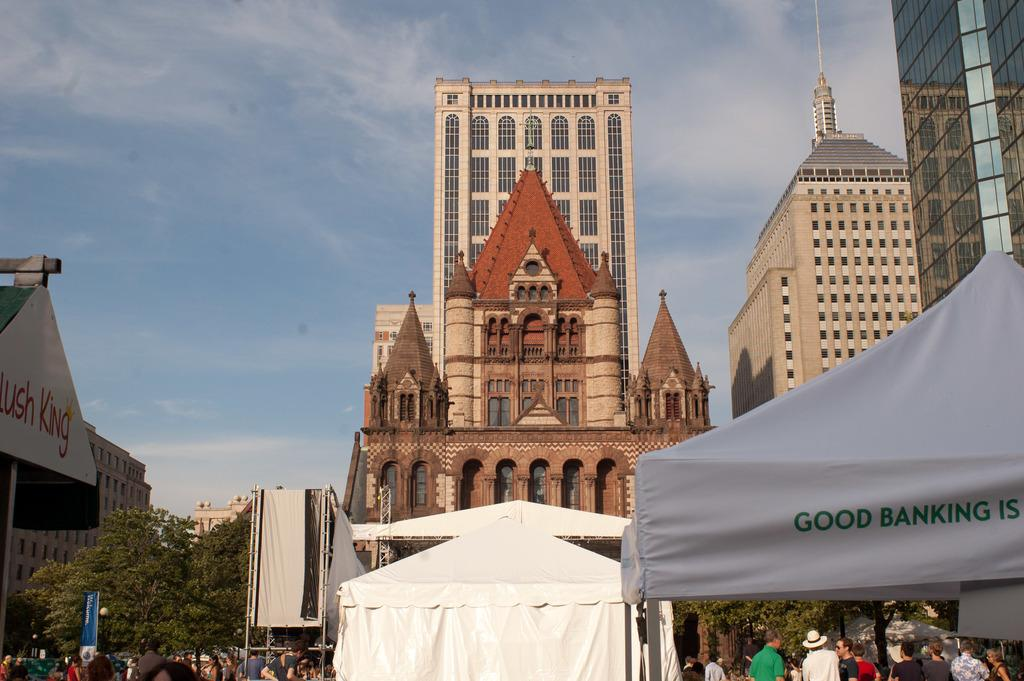What type of vegetation is on the left side of the image? There are trees on the left side of the image. What can be seen in the middle of the image? There are people and tents in the middle of the image. What type of structures are visible at the back side of the image? There are big buildings at the back side of the image. What is visible at the top of the image? The sky is visible at the top of the image. Where is the van parked in the image? There is no van present in the image. What memory does the locket hold in the image? There is no locket present in the image. 